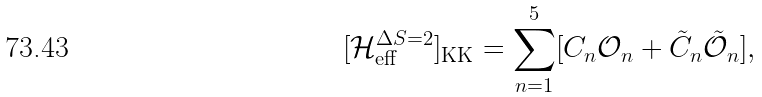Convert formula to latex. <formula><loc_0><loc_0><loc_500><loc_500>[ \mathcal { H } _ { \text {eff} } ^ { \Delta S = 2 } ] _ { \text {KK} } & = \sum _ { n = 1 } ^ { 5 } [ C _ { n } \mathcal { O } _ { n } + \tilde { C } _ { n } \tilde { \mathcal { O } } _ { n } ] ,</formula> 